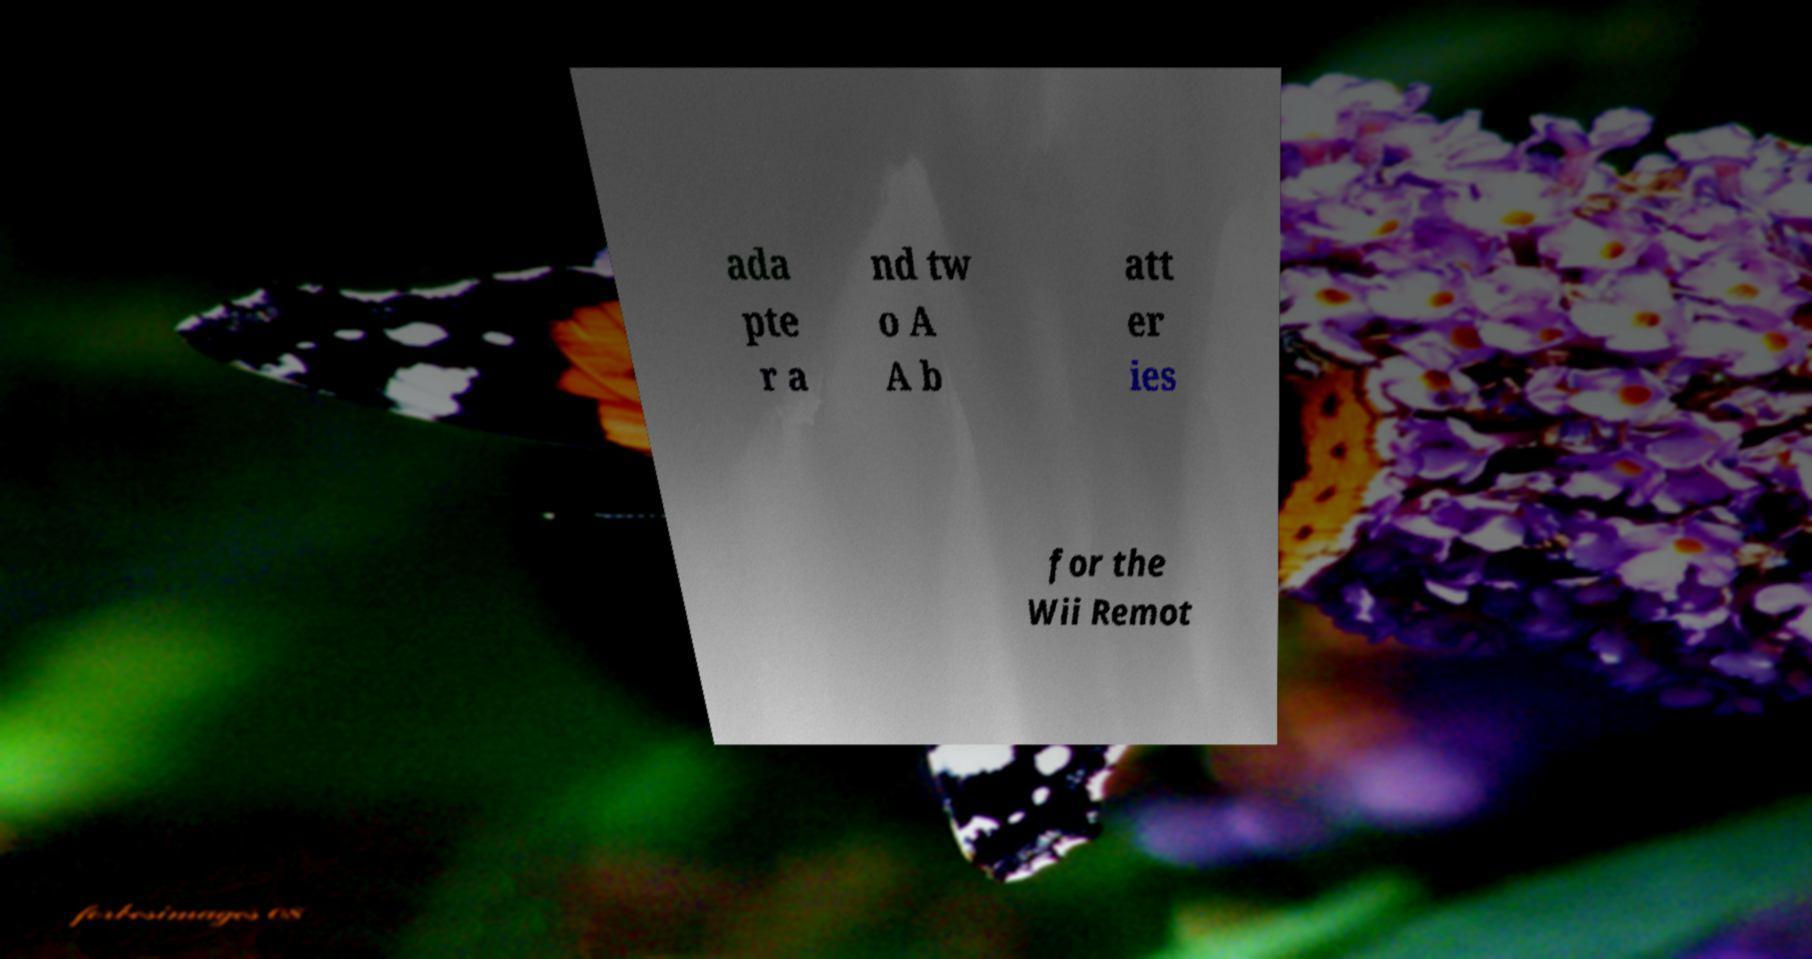What messages or text are displayed in this image? I need them in a readable, typed format. ada pte r a nd tw o A A b att er ies for the Wii Remot 